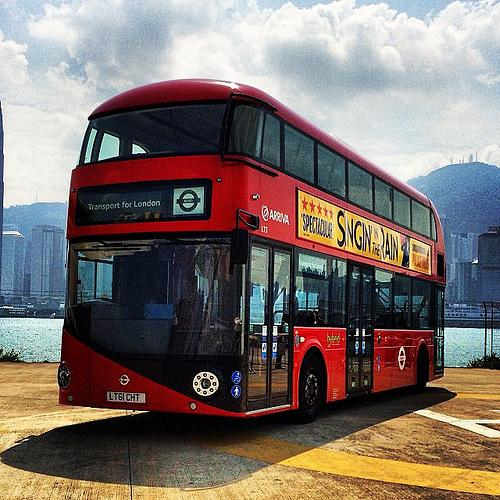Count the number of large windows on the bus. There are 11 large windows on the bus. What type of vehicle is at the center of the image and what color is it? A red and black transit bus, mainly red, is in the center of the image. Identify the natural phenomenon pictured in the image and describe its appearance. White clouds in the blue sky are the natural phenomena, appearing scattered throughout the image. How does the image make you feel, and why? The image feels calm and pleasant because of the serene waterway, clear blue sky, and picturesque background. Estimate the number of clouds present in the sky above. There seem to be around 9 distinct white clouds in the blue sky. Are there any doors visible on the bus? If so, how many? Yes, there are two doors visible on the bus - the front door and a passenger door in the middle. What type of landscape is visible in the background of the image? There are blue mountains in the horizon, a calm waterway, and some buildings in the background. Describe any notable decals, signs, or symbols found on the bus. There's a sign for Transport of London on the front, round blue stickers on the corner, and a black and white license plate. Analyze the bus's interaction with its surroundings. The bus is parked near calm water and casts a shadow, with its skyline reflected in the windows, while being surrounded by buildings and mountains in the background. Is there any advertisement visible on the side of the bus? If so, what color is it? Yes, there is a yellow billboard-style advertisement on the side of the bus. Does the reflection in the windows at X:296 Y:262 with Width:35 and Height:35 show a forest? The reflection shows the skyline, not a forest. Is there a dog standing beside the bus at X:5 Y:383 with Width:451 and Height:451? There is a shadow cast by the bus in this location, not a dog standing beside it. Is there a small car at X:81 Y:86 with Width:340 and Height:340? There is a red double decker bus at this location, not a small car. Is the green and yellow transit bus located at X:82 Y:78 with Width:358 and Height:358? The bus in the image is red and black, not green and yellow. Can you find a boat floating on the calm water at X:0 Y:312 with Width:495 and Height:495? No, it's not mentioned in the image. Can you see purple clouds in the sky at X:7 Y:11 with Width:48 and Height:48? The clouds in the image are white, not purple. 